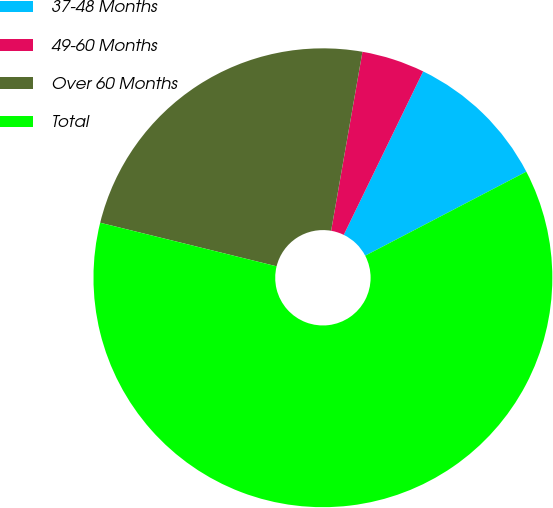<chart> <loc_0><loc_0><loc_500><loc_500><pie_chart><fcel>37-48 Months<fcel>49-60 Months<fcel>Over 60 Months<fcel>Total<nl><fcel>10.15%<fcel>4.44%<fcel>23.9%<fcel>61.5%<nl></chart> 